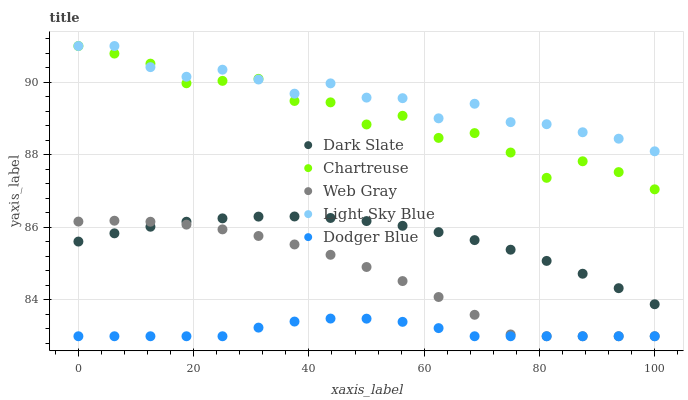Does Dodger Blue have the minimum area under the curve?
Answer yes or no. Yes. Does Light Sky Blue have the maximum area under the curve?
Answer yes or no. Yes. Does Chartreuse have the minimum area under the curve?
Answer yes or no. No. Does Chartreuse have the maximum area under the curve?
Answer yes or no. No. Is Dark Slate the smoothest?
Answer yes or no. Yes. Is Chartreuse the roughest?
Answer yes or no. Yes. Is Web Gray the smoothest?
Answer yes or no. No. Is Web Gray the roughest?
Answer yes or no. No. Does Web Gray have the lowest value?
Answer yes or no. Yes. Does Chartreuse have the lowest value?
Answer yes or no. No. Does Light Sky Blue have the highest value?
Answer yes or no. Yes. Does Web Gray have the highest value?
Answer yes or no. No. Is Dark Slate less than Chartreuse?
Answer yes or no. Yes. Is Chartreuse greater than Dark Slate?
Answer yes or no. Yes. Does Web Gray intersect Dodger Blue?
Answer yes or no. Yes. Is Web Gray less than Dodger Blue?
Answer yes or no. No. Is Web Gray greater than Dodger Blue?
Answer yes or no. No. Does Dark Slate intersect Chartreuse?
Answer yes or no. No. 